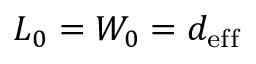<formula> <loc_0><loc_0><loc_500><loc_500>L _ { 0 } = W _ { 0 } = d _ { e f f }</formula> 